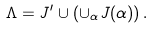Convert formula to latex. <formula><loc_0><loc_0><loc_500><loc_500>\Lambda = J ^ { \prime } \cup \left ( \cup _ { \alpha } J ( \alpha ) \right ) .</formula> 